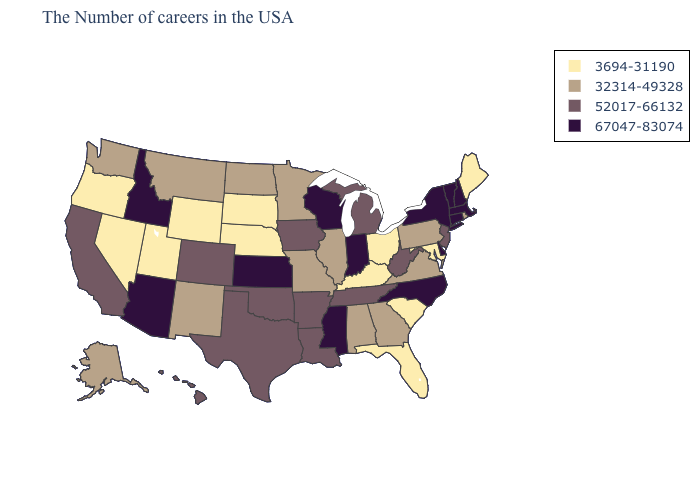Among the states that border Mississippi , which have the highest value?
Answer briefly. Tennessee, Louisiana, Arkansas. What is the value of Vermont?
Short answer required. 67047-83074. Among the states that border Tennessee , which have the lowest value?
Quick response, please. Kentucky. Among the states that border Kansas , which have the highest value?
Be succinct. Oklahoma, Colorado. What is the lowest value in the MidWest?
Concise answer only. 3694-31190. What is the lowest value in the USA?
Give a very brief answer. 3694-31190. What is the lowest value in states that border Michigan?
Quick response, please. 3694-31190. Which states have the lowest value in the USA?
Short answer required. Maine, Maryland, South Carolina, Ohio, Florida, Kentucky, Nebraska, South Dakota, Wyoming, Utah, Nevada, Oregon. Name the states that have a value in the range 3694-31190?
Keep it brief. Maine, Maryland, South Carolina, Ohio, Florida, Kentucky, Nebraska, South Dakota, Wyoming, Utah, Nevada, Oregon. Does New York have the lowest value in the Northeast?
Answer briefly. No. What is the highest value in the West ?
Write a very short answer. 67047-83074. Name the states that have a value in the range 67047-83074?
Quick response, please. Massachusetts, New Hampshire, Vermont, Connecticut, New York, Delaware, North Carolina, Indiana, Wisconsin, Mississippi, Kansas, Arizona, Idaho. What is the value of Florida?
Keep it brief. 3694-31190. What is the highest value in states that border Maine?
Write a very short answer. 67047-83074. Name the states that have a value in the range 32314-49328?
Short answer required. Rhode Island, Pennsylvania, Virginia, Georgia, Alabama, Illinois, Missouri, Minnesota, North Dakota, New Mexico, Montana, Washington, Alaska. 